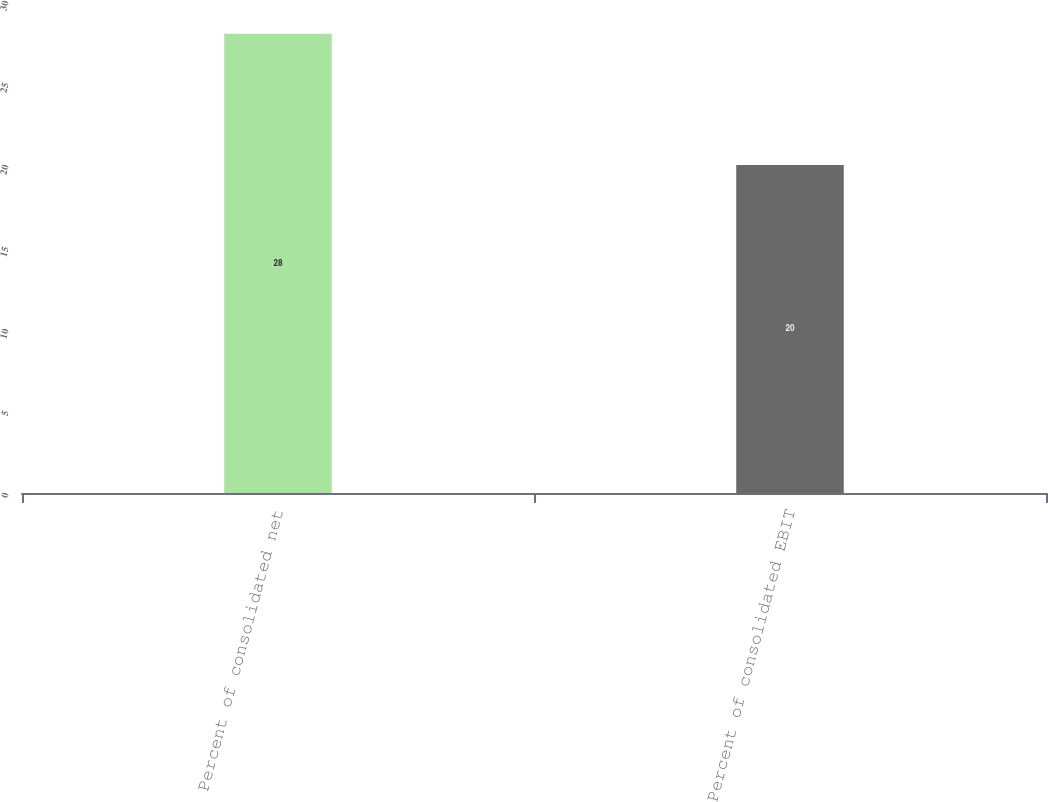Convert chart. <chart><loc_0><loc_0><loc_500><loc_500><bar_chart><fcel>Percent of consolidated net<fcel>Percent of consolidated EBIT<nl><fcel>28<fcel>20<nl></chart> 